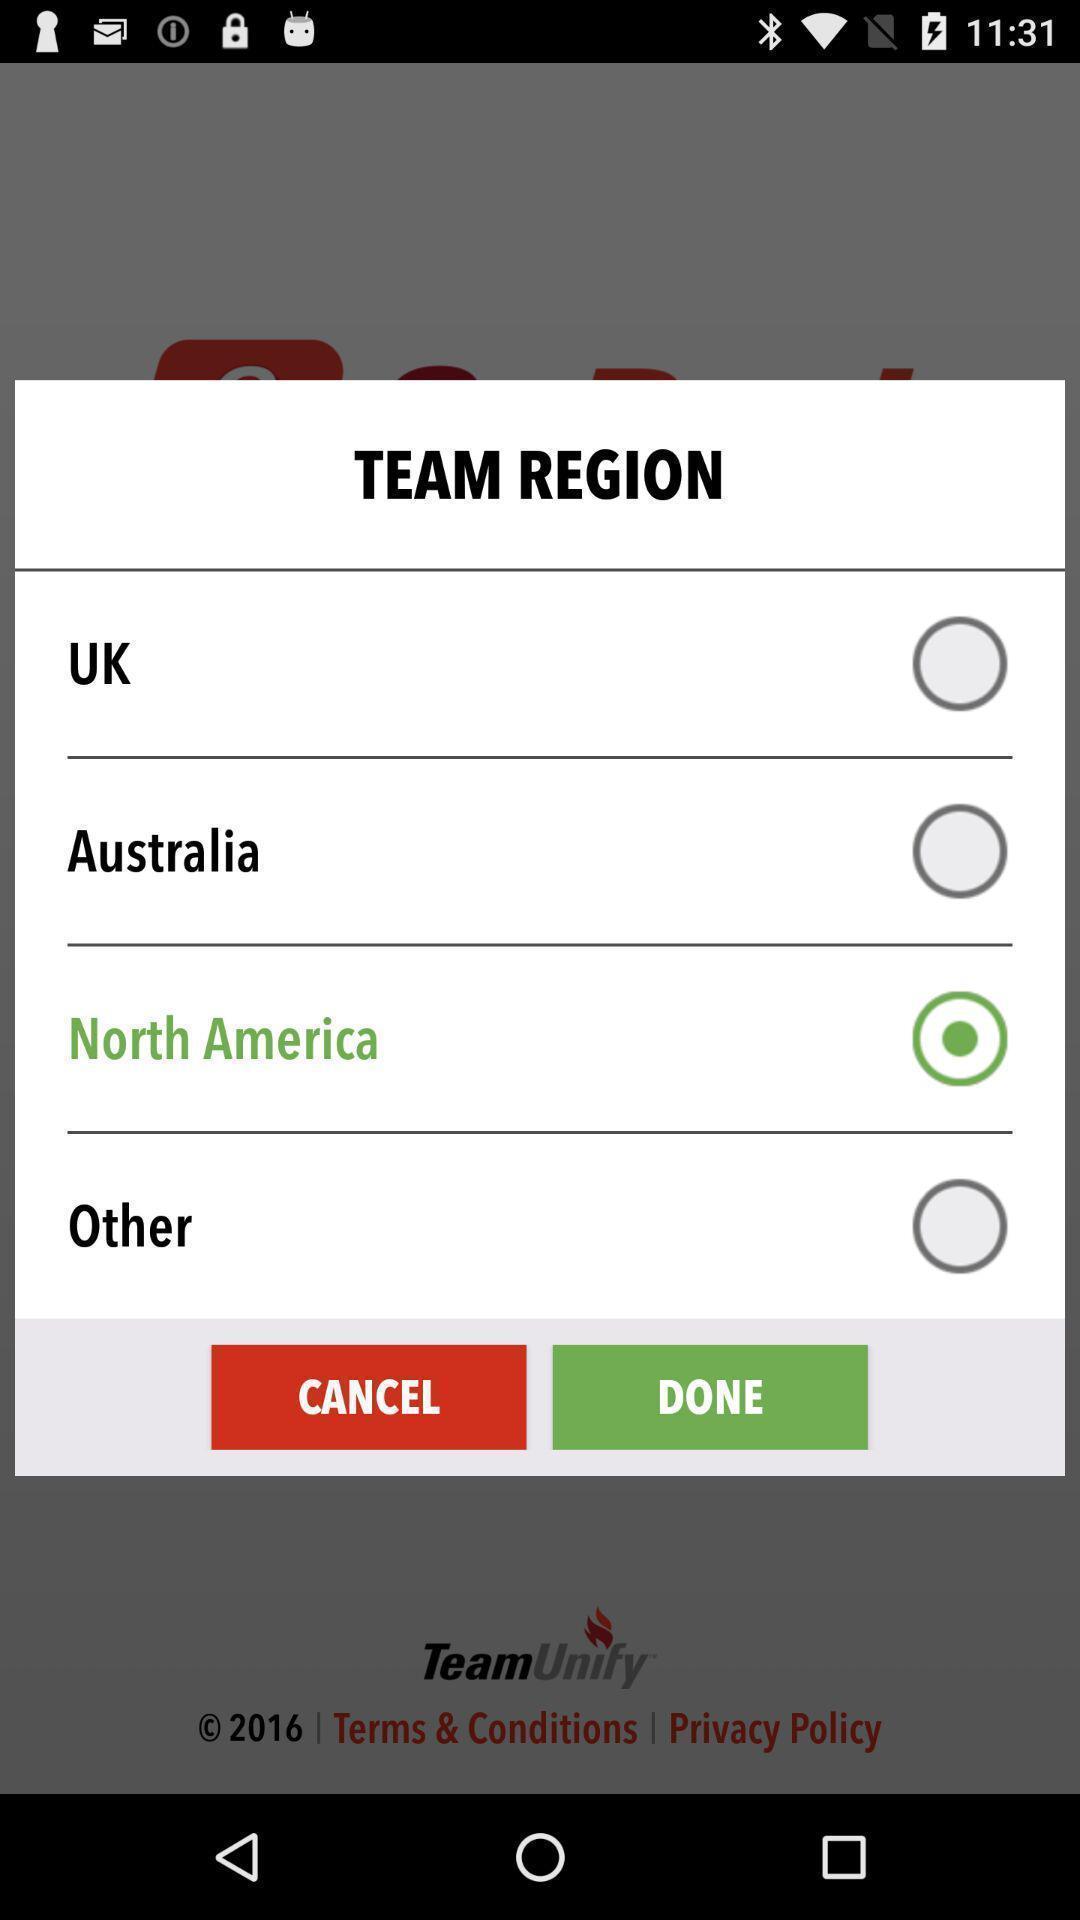Provide a textual representation of this image. Screen shows a team region to select. 